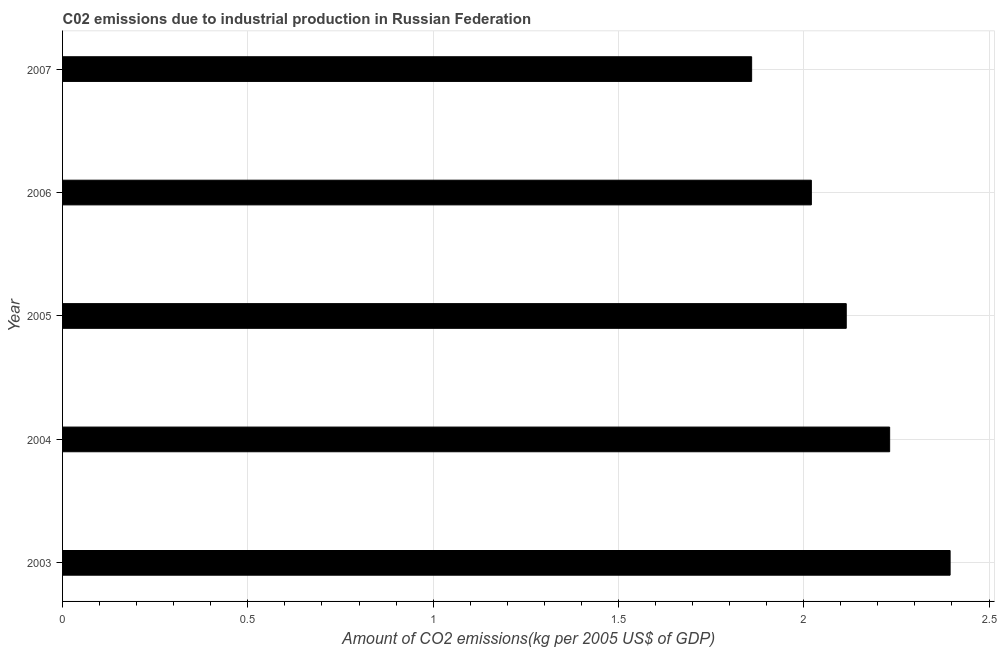Does the graph contain any zero values?
Give a very brief answer. No. What is the title of the graph?
Give a very brief answer. C02 emissions due to industrial production in Russian Federation. What is the label or title of the X-axis?
Keep it short and to the point. Amount of CO2 emissions(kg per 2005 US$ of GDP). What is the label or title of the Y-axis?
Make the answer very short. Year. What is the amount of co2 emissions in 2003?
Keep it short and to the point. 2.39. Across all years, what is the maximum amount of co2 emissions?
Offer a terse response. 2.39. Across all years, what is the minimum amount of co2 emissions?
Ensure brevity in your answer.  1.86. In which year was the amount of co2 emissions maximum?
Your response must be concise. 2003. In which year was the amount of co2 emissions minimum?
Your answer should be compact. 2007. What is the sum of the amount of co2 emissions?
Provide a short and direct response. 10.62. What is the difference between the amount of co2 emissions in 2004 and 2006?
Give a very brief answer. 0.21. What is the average amount of co2 emissions per year?
Provide a short and direct response. 2.12. What is the median amount of co2 emissions?
Give a very brief answer. 2.11. In how many years, is the amount of co2 emissions greater than 2.2 kg per 2005 US$ of GDP?
Your answer should be very brief. 2. Do a majority of the years between 2006 and 2004 (inclusive) have amount of co2 emissions greater than 0.9 kg per 2005 US$ of GDP?
Make the answer very short. Yes. What is the ratio of the amount of co2 emissions in 2003 to that in 2004?
Keep it short and to the point. 1.07. What is the difference between the highest and the second highest amount of co2 emissions?
Give a very brief answer. 0.16. What is the difference between the highest and the lowest amount of co2 emissions?
Make the answer very short. 0.54. How many bars are there?
Provide a succinct answer. 5. Are all the bars in the graph horizontal?
Offer a very short reply. Yes. What is the difference between two consecutive major ticks on the X-axis?
Your answer should be compact. 0.5. What is the Amount of CO2 emissions(kg per 2005 US$ of GDP) in 2003?
Your response must be concise. 2.39. What is the Amount of CO2 emissions(kg per 2005 US$ of GDP) of 2004?
Offer a terse response. 2.23. What is the Amount of CO2 emissions(kg per 2005 US$ of GDP) in 2005?
Provide a succinct answer. 2.11. What is the Amount of CO2 emissions(kg per 2005 US$ of GDP) in 2006?
Provide a short and direct response. 2.02. What is the Amount of CO2 emissions(kg per 2005 US$ of GDP) of 2007?
Your answer should be compact. 1.86. What is the difference between the Amount of CO2 emissions(kg per 2005 US$ of GDP) in 2003 and 2004?
Your answer should be compact. 0.16. What is the difference between the Amount of CO2 emissions(kg per 2005 US$ of GDP) in 2003 and 2005?
Your answer should be very brief. 0.28. What is the difference between the Amount of CO2 emissions(kg per 2005 US$ of GDP) in 2003 and 2006?
Provide a short and direct response. 0.37. What is the difference between the Amount of CO2 emissions(kg per 2005 US$ of GDP) in 2003 and 2007?
Offer a terse response. 0.54. What is the difference between the Amount of CO2 emissions(kg per 2005 US$ of GDP) in 2004 and 2005?
Give a very brief answer. 0.12. What is the difference between the Amount of CO2 emissions(kg per 2005 US$ of GDP) in 2004 and 2006?
Your answer should be compact. 0.21. What is the difference between the Amount of CO2 emissions(kg per 2005 US$ of GDP) in 2004 and 2007?
Keep it short and to the point. 0.37. What is the difference between the Amount of CO2 emissions(kg per 2005 US$ of GDP) in 2005 and 2006?
Ensure brevity in your answer.  0.09. What is the difference between the Amount of CO2 emissions(kg per 2005 US$ of GDP) in 2005 and 2007?
Your answer should be very brief. 0.26. What is the difference between the Amount of CO2 emissions(kg per 2005 US$ of GDP) in 2006 and 2007?
Your answer should be compact. 0.16. What is the ratio of the Amount of CO2 emissions(kg per 2005 US$ of GDP) in 2003 to that in 2004?
Your answer should be compact. 1.07. What is the ratio of the Amount of CO2 emissions(kg per 2005 US$ of GDP) in 2003 to that in 2005?
Provide a succinct answer. 1.13. What is the ratio of the Amount of CO2 emissions(kg per 2005 US$ of GDP) in 2003 to that in 2006?
Offer a very short reply. 1.19. What is the ratio of the Amount of CO2 emissions(kg per 2005 US$ of GDP) in 2003 to that in 2007?
Give a very brief answer. 1.29. What is the ratio of the Amount of CO2 emissions(kg per 2005 US$ of GDP) in 2004 to that in 2005?
Your answer should be very brief. 1.05. What is the ratio of the Amount of CO2 emissions(kg per 2005 US$ of GDP) in 2004 to that in 2006?
Provide a short and direct response. 1.1. What is the ratio of the Amount of CO2 emissions(kg per 2005 US$ of GDP) in 2005 to that in 2006?
Keep it short and to the point. 1.05. What is the ratio of the Amount of CO2 emissions(kg per 2005 US$ of GDP) in 2005 to that in 2007?
Keep it short and to the point. 1.14. What is the ratio of the Amount of CO2 emissions(kg per 2005 US$ of GDP) in 2006 to that in 2007?
Ensure brevity in your answer.  1.09. 